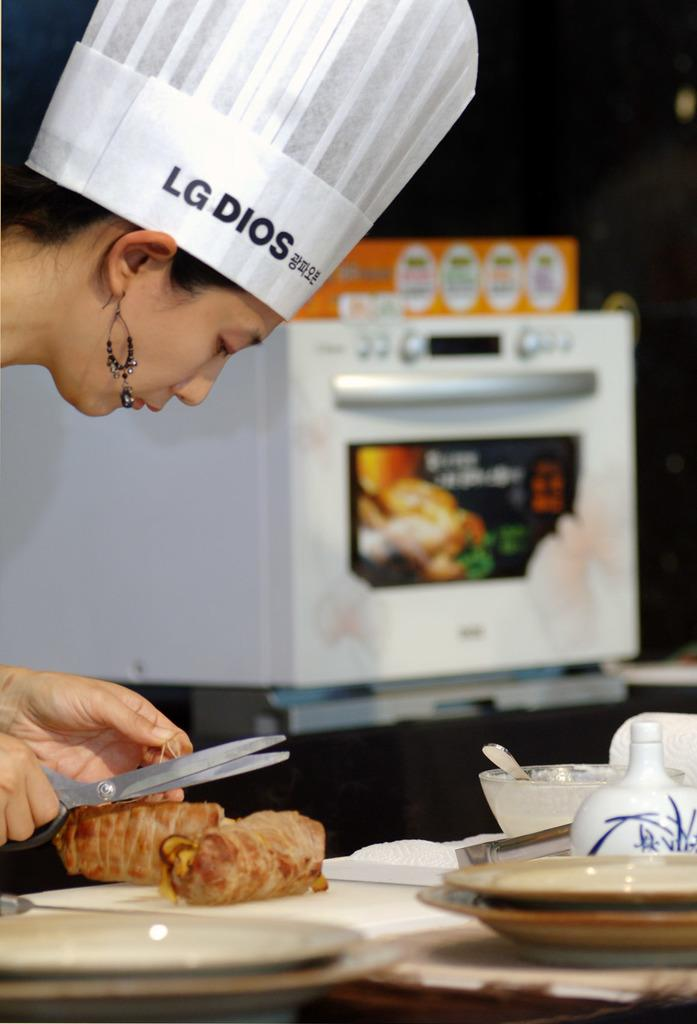<image>
Write a terse but informative summary of the picture. A woman preparing meat rolls wears beaded earrings and a hat saying "LG Dios". 